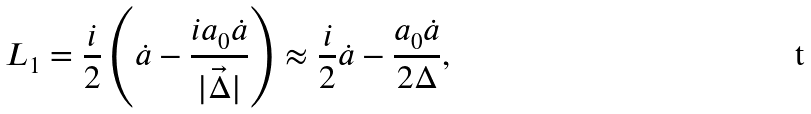<formula> <loc_0><loc_0><loc_500><loc_500>L _ { 1 } = \frac { i } { 2 } \left ( \dot { a } - \frac { i a _ { 0 } \dot { a } } { | \vec { \Delta } | } \right ) \approx \frac { i } { 2 } \dot { a } - \frac { a _ { 0 } \dot { a } } { 2 \Delta } ,</formula> 